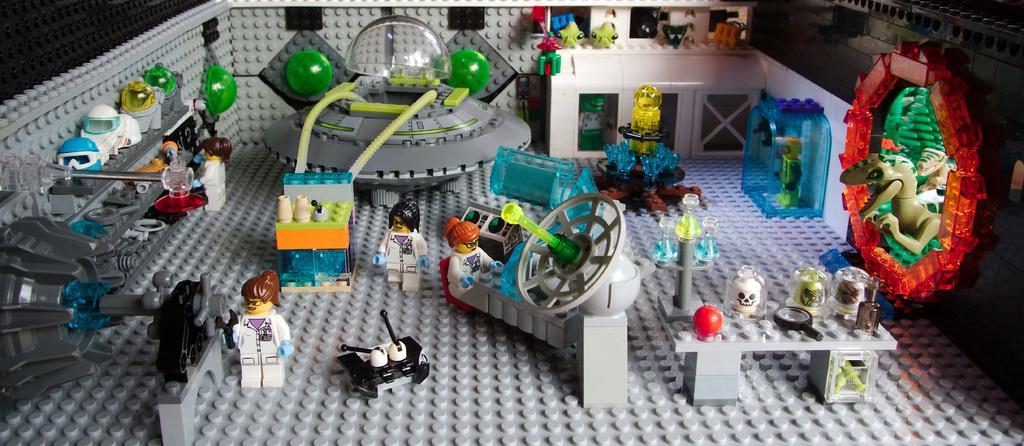Can you describe this image briefly? In this picture we can see Lego puzzle, there are people, animals, helmets, cups and objects. 